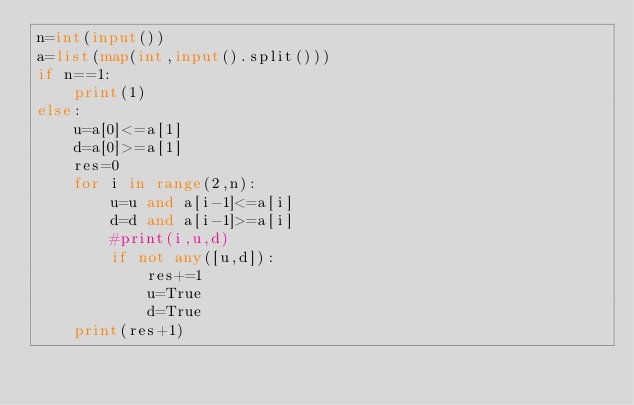<code> <loc_0><loc_0><loc_500><loc_500><_Python_>n=int(input())
a=list(map(int,input().split()))
if n==1:
    print(1)
else:
    u=a[0]<=a[1]
    d=a[0]>=a[1]
    res=0
    for i in range(2,n):
        u=u and a[i-1]<=a[i]
        d=d and a[i-1]>=a[i]
        #print(i,u,d)
        if not any([u,d]):
            res+=1
            u=True
            d=True
    print(res+1)
    </code> 